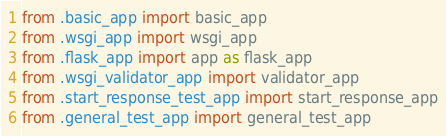<code> <loc_0><loc_0><loc_500><loc_500><_Python_>from .basic_app import basic_app
from .wsgi_app import wsgi_app
from .flask_app import app as flask_app
from .wsgi_validator_app import validator_app
from .start_response_test_app import start_response_app
from .general_test_app import general_test_app
</code> 